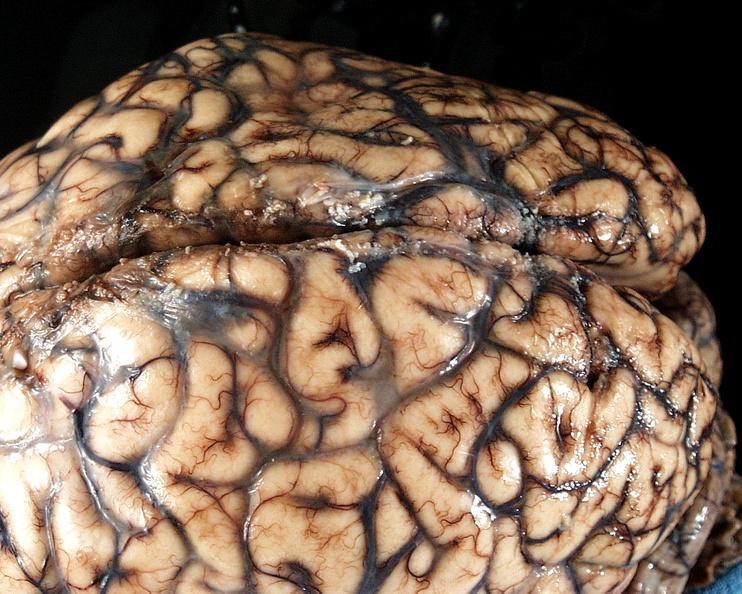does pus in test tube show brain, cryptococcal meningitis?
Answer the question using a single word or phrase. No 